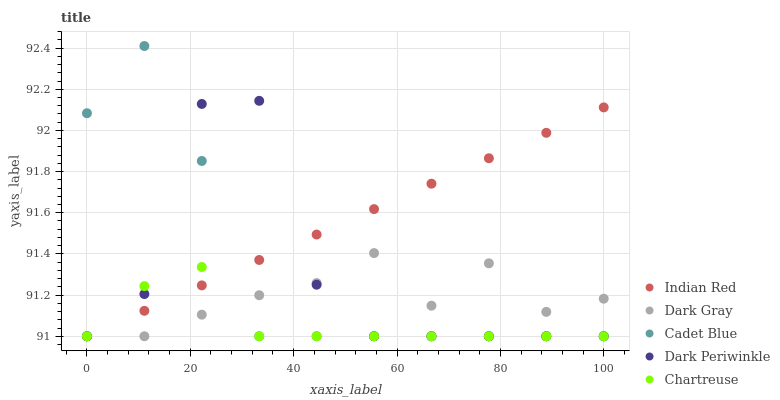Does Chartreuse have the minimum area under the curve?
Answer yes or no. Yes. Does Indian Red have the maximum area under the curve?
Answer yes or no. Yes. Does Cadet Blue have the minimum area under the curve?
Answer yes or no. No. Does Cadet Blue have the maximum area under the curve?
Answer yes or no. No. Is Indian Red the smoothest?
Answer yes or no. Yes. Is Dark Periwinkle the roughest?
Answer yes or no. Yes. Is Chartreuse the smoothest?
Answer yes or no. No. Is Chartreuse the roughest?
Answer yes or no. No. Does Dark Gray have the lowest value?
Answer yes or no. Yes. Does Cadet Blue have the highest value?
Answer yes or no. Yes. Does Chartreuse have the highest value?
Answer yes or no. No. Does Dark Periwinkle intersect Cadet Blue?
Answer yes or no. Yes. Is Dark Periwinkle less than Cadet Blue?
Answer yes or no. No. Is Dark Periwinkle greater than Cadet Blue?
Answer yes or no. No. 